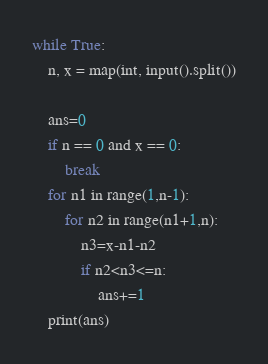Convert code to text. <code><loc_0><loc_0><loc_500><loc_500><_Python_>while True:
    n, x = map(int, input().split())

    ans=0
    if n == 0 and x == 0:
        break
    for n1 in range(1,n-1):
        for n2 in range(n1+1,n):
            n3=x-n1-n2
            if n2<n3<=n:
                ans+=1
    print(ans)
</code> 